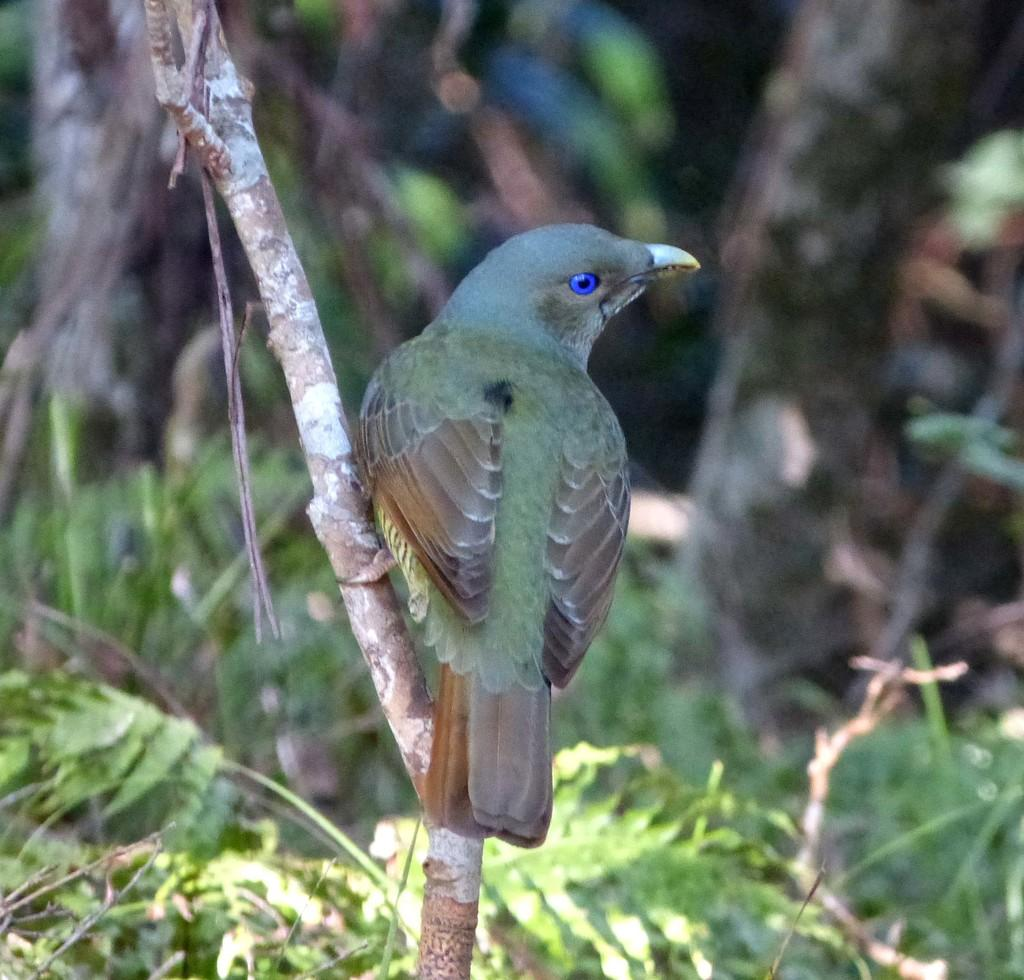What type of animal can be seen in the image? There is a bird in the image. Where is the bird located in the image? The bird is sitting on a stem. What else can be seen in the image besides the bird? There are leaves visible in the image. How would you describe the background of the image? The background of the image is blurred. What type of hair can be seen on the bird in the image? There is no hair visible on the bird in the image, as birds do not have hair. 